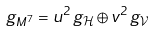<formula> <loc_0><loc_0><loc_500><loc_500>g _ { M ^ { 7 } } = u ^ { 2 } \, g _ { \mathcal { H } } \oplus v ^ { 2 } \, g _ { \mathcal { V } }</formula> 